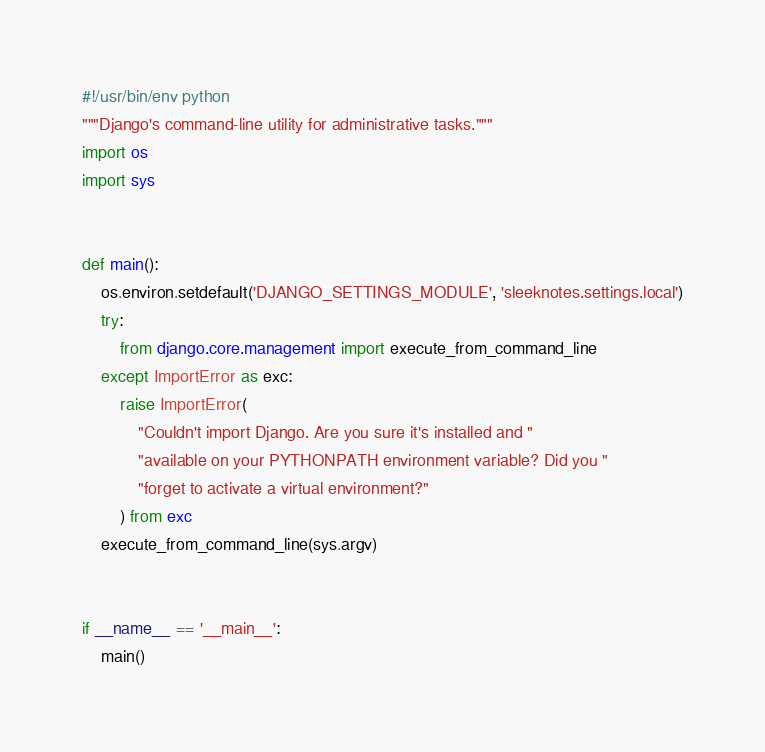<code> <loc_0><loc_0><loc_500><loc_500><_Python_>#!/usr/bin/env python
"""Django's command-line utility for administrative tasks."""
import os
import sys


def main():
    os.environ.setdefault('DJANGO_SETTINGS_MODULE', 'sleeknotes.settings.local')
    try:
        from django.core.management import execute_from_command_line
    except ImportError as exc:
        raise ImportError(
            "Couldn't import Django. Are you sure it's installed and "
            "available on your PYTHONPATH environment variable? Did you "
            "forget to activate a virtual environment?"
        ) from exc
    execute_from_command_line(sys.argv)


if __name__ == '__main__':
    main()
</code> 